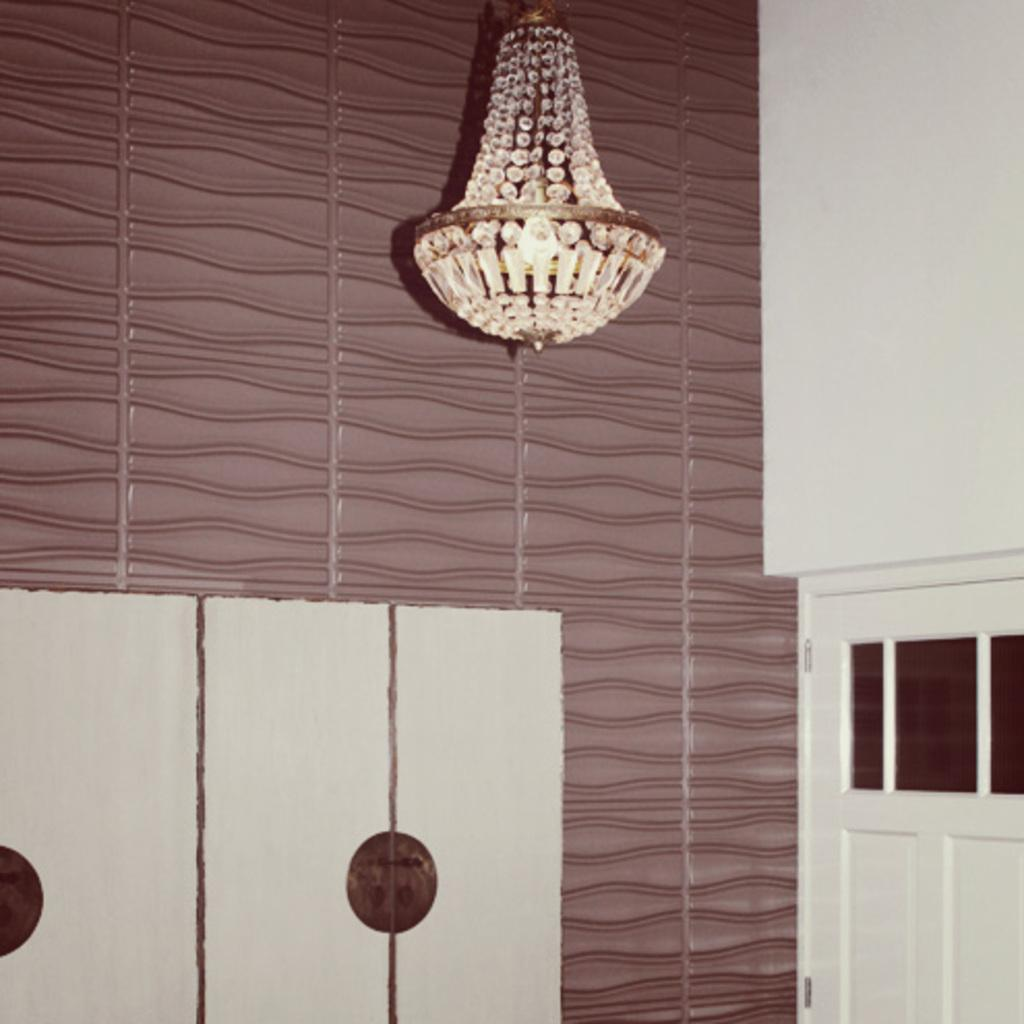What is one of the main architectural features in the image? There is a door in the image. What type of lighting fixture can be seen in the image? There is a chandelier in the image. What can be seen in the background of the image? There is a design wall in the background of the image. What type of haircut does the lawyer have in the image? There is no lawyer present in the image, and therefore no haircut to describe. 